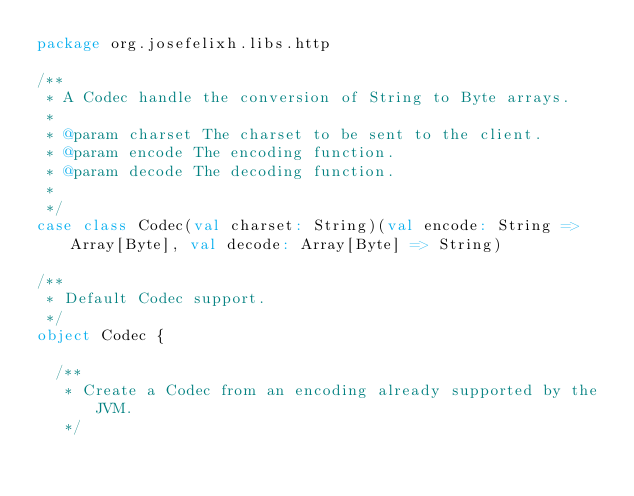<code> <loc_0><loc_0><loc_500><loc_500><_Scala_>package org.josefelixh.libs.http

/**
 * A Codec handle the conversion of String to Byte arrays.
 *
 * @param charset The charset to be sent to the client.
 * @param encode The encoding function.
 * @param decode The decoding function.
 *
 */
case class Codec(val charset: String)(val encode: String => Array[Byte], val decode: Array[Byte] => String)

/**
 * Default Codec support.
 */
object Codec {

  /**
   * Create a Codec from an encoding already supported by the JVM.
   */</code> 